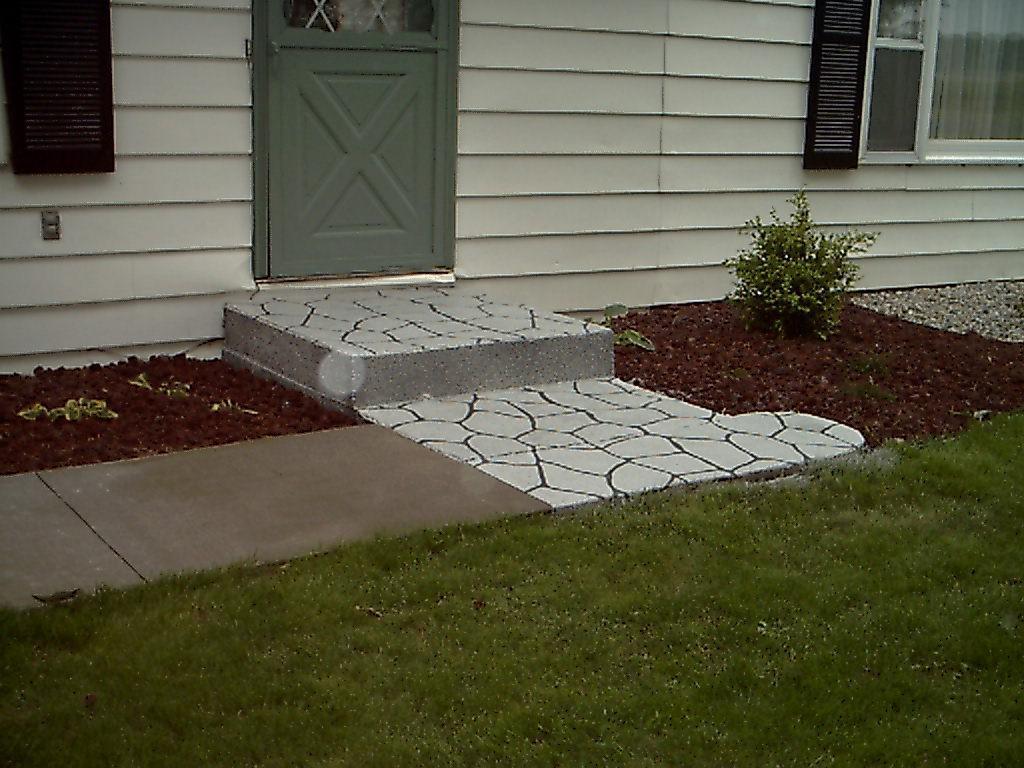Describe this image in one or two sentences. As we can see in the image is house, door, window and plant. In the front there is grass. 